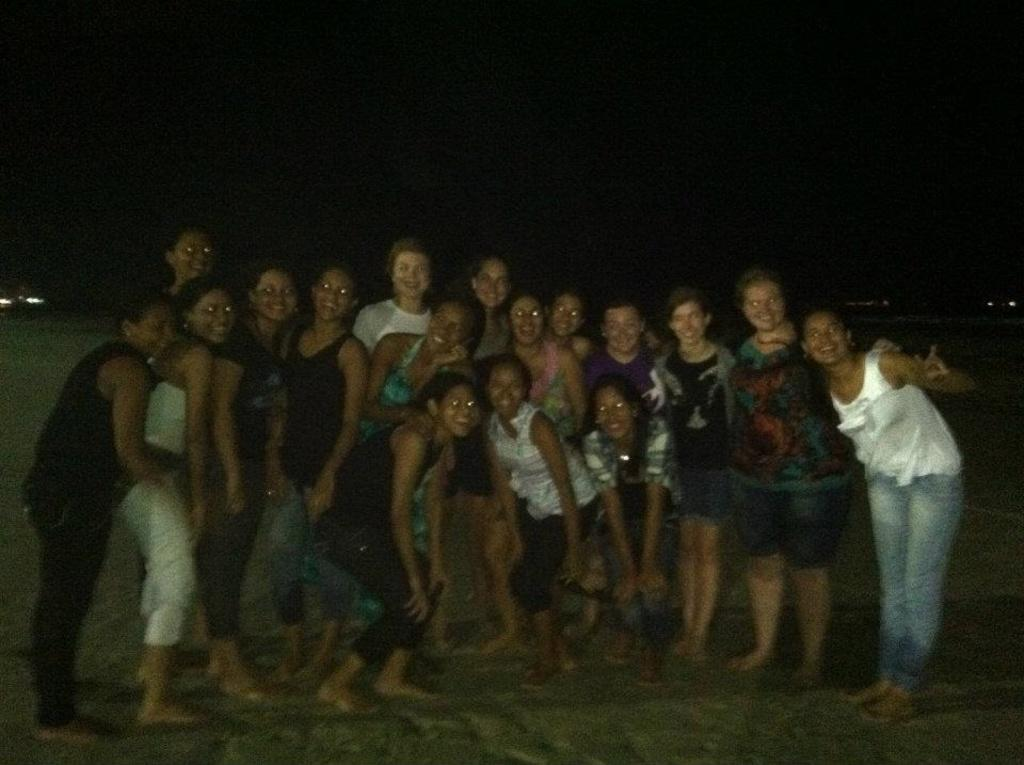What is the main subject of the picture? The main subject of the picture is a group of women. Where are the women located in the image? The women are standing on the ground. What is the facial expression of the women in the image? The women are smiling. What type of liquid can be seen in the image? There is no liquid present in the image; it features a group of women standing on the ground and smiling. 